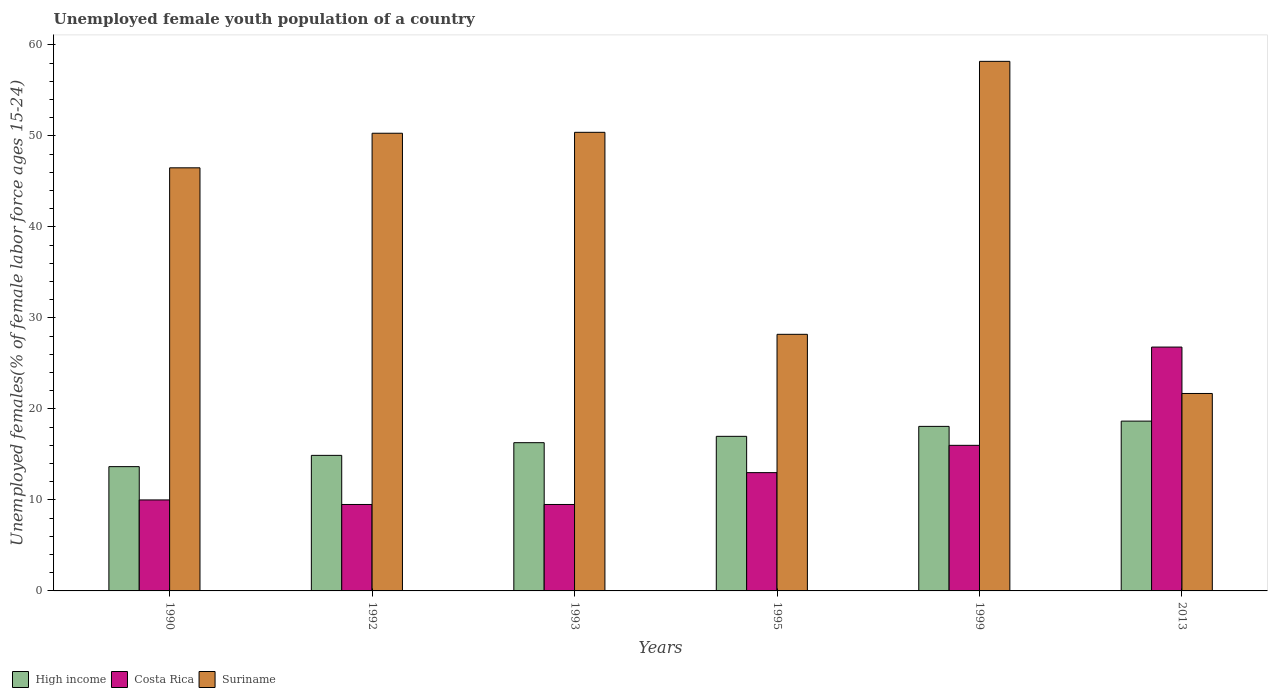What is the label of the 3rd group of bars from the left?
Your answer should be compact. 1993. What is the percentage of unemployed female youth population in Costa Rica in 1995?
Offer a very short reply. 13. Across all years, what is the maximum percentage of unemployed female youth population in Suriname?
Offer a very short reply. 58.2. Across all years, what is the minimum percentage of unemployed female youth population in Suriname?
Your response must be concise. 21.7. In which year was the percentage of unemployed female youth population in Costa Rica maximum?
Offer a terse response. 2013. In which year was the percentage of unemployed female youth population in High income minimum?
Make the answer very short. 1990. What is the total percentage of unemployed female youth population in High income in the graph?
Provide a succinct answer. 98.58. What is the difference between the percentage of unemployed female youth population in Costa Rica in 1990 and that in 2013?
Give a very brief answer. -16.8. What is the difference between the percentage of unemployed female youth population in High income in 1993 and the percentage of unemployed female youth population in Costa Rica in 1990?
Your answer should be compact. 6.29. What is the average percentage of unemployed female youth population in Costa Rica per year?
Keep it short and to the point. 14.13. In the year 1999, what is the difference between the percentage of unemployed female youth population in High income and percentage of unemployed female youth population in Costa Rica?
Give a very brief answer. 2.08. In how many years, is the percentage of unemployed female youth population in Suriname greater than 6 %?
Give a very brief answer. 6. Is the percentage of unemployed female youth population in Costa Rica in 1992 less than that in 1993?
Your response must be concise. No. Is the difference between the percentage of unemployed female youth population in High income in 1993 and 2013 greater than the difference between the percentage of unemployed female youth population in Costa Rica in 1993 and 2013?
Make the answer very short. Yes. What is the difference between the highest and the second highest percentage of unemployed female youth population in High income?
Ensure brevity in your answer.  0.58. What is the difference between the highest and the lowest percentage of unemployed female youth population in Suriname?
Provide a succinct answer. 36.5. What does the 1st bar from the right in 1999 represents?
Your response must be concise. Suriname. Is it the case that in every year, the sum of the percentage of unemployed female youth population in High income and percentage of unemployed female youth population in Suriname is greater than the percentage of unemployed female youth population in Costa Rica?
Offer a terse response. Yes. How many years are there in the graph?
Provide a succinct answer. 6. Does the graph contain any zero values?
Offer a very short reply. No. Does the graph contain grids?
Your answer should be compact. No. What is the title of the graph?
Ensure brevity in your answer.  Unemployed female youth population of a country. Does "Congo (Republic)" appear as one of the legend labels in the graph?
Provide a succinct answer. No. What is the label or title of the X-axis?
Provide a succinct answer. Years. What is the label or title of the Y-axis?
Your answer should be very brief. Unemployed females(% of female labor force ages 15-24). What is the Unemployed females(% of female labor force ages 15-24) of High income in 1990?
Make the answer very short. 13.66. What is the Unemployed females(% of female labor force ages 15-24) of Suriname in 1990?
Your answer should be compact. 46.5. What is the Unemployed females(% of female labor force ages 15-24) of High income in 1992?
Your answer should be compact. 14.9. What is the Unemployed females(% of female labor force ages 15-24) of Suriname in 1992?
Your answer should be very brief. 50.3. What is the Unemployed females(% of female labor force ages 15-24) in High income in 1993?
Provide a succinct answer. 16.29. What is the Unemployed females(% of female labor force ages 15-24) in Suriname in 1993?
Offer a terse response. 50.4. What is the Unemployed females(% of female labor force ages 15-24) in High income in 1995?
Your response must be concise. 16.99. What is the Unemployed females(% of female labor force ages 15-24) of Suriname in 1995?
Your answer should be very brief. 28.2. What is the Unemployed females(% of female labor force ages 15-24) of High income in 1999?
Provide a short and direct response. 18.08. What is the Unemployed females(% of female labor force ages 15-24) in Suriname in 1999?
Provide a short and direct response. 58.2. What is the Unemployed females(% of female labor force ages 15-24) in High income in 2013?
Provide a succinct answer. 18.66. What is the Unemployed females(% of female labor force ages 15-24) of Costa Rica in 2013?
Give a very brief answer. 26.8. What is the Unemployed females(% of female labor force ages 15-24) in Suriname in 2013?
Your response must be concise. 21.7. Across all years, what is the maximum Unemployed females(% of female labor force ages 15-24) in High income?
Give a very brief answer. 18.66. Across all years, what is the maximum Unemployed females(% of female labor force ages 15-24) in Costa Rica?
Ensure brevity in your answer.  26.8. Across all years, what is the maximum Unemployed females(% of female labor force ages 15-24) in Suriname?
Make the answer very short. 58.2. Across all years, what is the minimum Unemployed females(% of female labor force ages 15-24) of High income?
Your response must be concise. 13.66. Across all years, what is the minimum Unemployed females(% of female labor force ages 15-24) of Costa Rica?
Your answer should be very brief. 9.5. Across all years, what is the minimum Unemployed females(% of female labor force ages 15-24) in Suriname?
Keep it short and to the point. 21.7. What is the total Unemployed females(% of female labor force ages 15-24) in High income in the graph?
Make the answer very short. 98.58. What is the total Unemployed females(% of female labor force ages 15-24) of Costa Rica in the graph?
Make the answer very short. 84.8. What is the total Unemployed females(% of female labor force ages 15-24) of Suriname in the graph?
Keep it short and to the point. 255.3. What is the difference between the Unemployed females(% of female labor force ages 15-24) in High income in 1990 and that in 1992?
Provide a short and direct response. -1.24. What is the difference between the Unemployed females(% of female labor force ages 15-24) in High income in 1990 and that in 1993?
Provide a short and direct response. -2.63. What is the difference between the Unemployed females(% of female labor force ages 15-24) of High income in 1990 and that in 1995?
Provide a short and direct response. -3.33. What is the difference between the Unemployed females(% of female labor force ages 15-24) in Suriname in 1990 and that in 1995?
Make the answer very short. 18.3. What is the difference between the Unemployed females(% of female labor force ages 15-24) of High income in 1990 and that in 1999?
Make the answer very short. -4.42. What is the difference between the Unemployed females(% of female labor force ages 15-24) in High income in 1990 and that in 2013?
Provide a succinct answer. -5. What is the difference between the Unemployed females(% of female labor force ages 15-24) in Costa Rica in 1990 and that in 2013?
Ensure brevity in your answer.  -16.8. What is the difference between the Unemployed females(% of female labor force ages 15-24) in Suriname in 1990 and that in 2013?
Keep it short and to the point. 24.8. What is the difference between the Unemployed females(% of female labor force ages 15-24) of High income in 1992 and that in 1993?
Offer a very short reply. -1.4. What is the difference between the Unemployed females(% of female labor force ages 15-24) in Costa Rica in 1992 and that in 1993?
Your response must be concise. 0. What is the difference between the Unemployed females(% of female labor force ages 15-24) in Suriname in 1992 and that in 1993?
Provide a succinct answer. -0.1. What is the difference between the Unemployed females(% of female labor force ages 15-24) of High income in 1992 and that in 1995?
Your answer should be very brief. -2.09. What is the difference between the Unemployed females(% of female labor force ages 15-24) of Suriname in 1992 and that in 1995?
Keep it short and to the point. 22.1. What is the difference between the Unemployed females(% of female labor force ages 15-24) in High income in 1992 and that in 1999?
Make the answer very short. -3.19. What is the difference between the Unemployed females(% of female labor force ages 15-24) in Costa Rica in 1992 and that in 1999?
Offer a terse response. -6.5. What is the difference between the Unemployed females(% of female labor force ages 15-24) in High income in 1992 and that in 2013?
Offer a very short reply. -3.76. What is the difference between the Unemployed females(% of female labor force ages 15-24) in Costa Rica in 1992 and that in 2013?
Provide a short and direct response. -17.3. What is the difference between the Unemployed females(% of female labor force ages 15-24) in Suriname in 1992 and that in 2013?
Ensure brevity in your answer.  28.6. What is the difference between the Unemployed females(% of female labor force ages 15-24) in High income in 1993 and that in 1995?
Provide a short and direct response. -0.7. What is the difference between the Unemployed females(% of female labor force ages 15-24) of Suriname in 1993 and that in 1995?
Provide a succinct answer. 22.2. What is the difference between the Unemployed females(% of female labor force ages 15-24) of High income in 1993 and that in 1999?
Offer a very short reply. -1.79. What is the difference between the Unemployed females(% of female labor force ages 15-24) in Costa Rica in 1993 and that in 1999?
Keep it short and to the point. -6.5. What is the difference between the Unemployed females(% of female labor force ages 15-24) of Suriname in 1993 and that in 1999?
Make the answer very short. -7.8. What is the difference between the Unemployed females(% of female labor force ages 15-24) in High income in 1993 and that in 2013?
Provide a short and direct response. -2.37. What is the difference between the Unemployed females(% of female labor force ages 15-24) in Costa Rica in 1993 and that in 2013?
Your response must be concise. -17.3. What is the difference between the Unemployed females(% of female labor force ages 15-24) of Suriname in 1993 and that in 2013?
Offer a terse response. 28.7. What is the difference between the Unemployed females(% of female labor force ages 15-24) of High income in 1995 and that in 1999?
Make the answer very short. -1.09. What is the difference between the Unemployed females(% of female labor force ages 15-24) of High income in 1995 and that in 2013?
Your response must be concise. -1.67. What is the difference between the Unemployed females(% of female labor force ages 15-24) in Costa Rica in 1995 and that in 2013?
Your answer should be compact. -13.8. What is the difference between the Unemployed females(% of female labor force ages 15-24) of Suriname in 1995 and that in 2013?
Provide a short and direct response. 6.5. What is the difference between the Unemployed females(% of female labor force ages 15-24) of High income in 1999 and that in 2013?
Your answer should be compact. -0.58. What is the difference between the Unemployed females(% of female labor force ages 15-24) of Suriname in 1999 and that in 2013?
Offer a very short reply. 36.5. What is the difference between the Unemployed females(% of female labor force ages 15-24) in High income in 1990 and the Unemployed females(% of female labor force ages 15-24) in Costa Rica in 1992?
Offer a very short reply. 4.16. What is the difference between the Unemployed females(% of female labor force ages 15-24) of High income in 1990 and the Unemployed females(% of female labor force ages 15-24) of Suriname in 1992?
Ensure brevity in your answer.  -36.64. What is the difference between the Unemployed females(% of female labor force ages 15-24) of Costa Rica in 1990 and the Unemployed females(% of female labor force ages 15-24) of Suriname in 1992?
Provide a succinct answer. -40.3. What is the difference between the Unemployed females(% of female labor force ages 15-24) in High income in 1990 and the Unemployed females(% of female labor force ages 15-24) in Costa Rica in 1993?
Your answer should be very brief. 4.16. What is the difference between the Unemployed females(% of female labor force ages 15-24) of High income in 1990 and the Unemployed females(% of female labor force ages 15-24) of Suriname in 1993?
Your answer should be very brief. -36.74. What is the difference between the Unemployed females(% of female labor force ages 15-24) of Costa Rica in 1990 and the Unemployed females(% of female labor force ages 15-24) of Suriname in 1993?
Provide a short and direct response. -40.4. What is the difference between the Unemployed females(% of female labor force ages 15-24) of High income in 1990 and the Unemployed females(% of female labor force ages 15-24) of Costa Rica in 1995?
Offer a very short reply. 0.66. What is the difference between the Unemployed females(% of female labor force ages 15-24) in High income in 1990 and the Unemployed females(% of female labor force ages 15-24) in Suriname in 1995?
Offer a very short reply. -14.54. What is the difference between the Unemployed females(% of female labor force ages 15-24) of Costa Rica in 1990 and the Unemployed females(% of female labor force ages 15-24) of Suriname in 1995?
Offer a very short reply. -18.2. What is the difference between the Unemployed females(% of female labor force ages 15-24) in High income in 1990 and the Unemployed females(% of female labor force ages 15-24) in Costa Rica in 1999?
Keep it short and to the point. -2.34. What is the difference between the Unemployed females(% of female labor force ages 15-24) of High income in 1990 and the Unemployed females(% of female labor force ages 15-24) of Suriname in 1999?
Ensure brevity in your answer.  -44.54. What is the difference between the Unemployed females(% of female labor force ages 15-24) of Costa Rica in 1990 and the Unemployed females(% of female labor force ages 15-24) of Suriname in 1999?
Your answer should be compact. -48.2. What is the difference between the Unemployed females(% of female labor force ages 15-24) of High income in 1990 and the Unemployed females(% of female labor force ages 15-24) of Costa Rica in 2013?
Ensure brevity in your answer.  -13.14. What is the difference between the Unemployed females(% of female labor force ages 15-24) in High income in 1990 and the Unemployed females(% of female labor force ages 15-24) in Suriname in 2013?
Make the answer very short. -8.04. What is the difference between the Unemployed females(% of female labor force ages 15-24) of Costa Rica in 1990 and the Unemployed females(% of female labor force ages 15-24) of Suriname in 2013?
Provide a succinct answer. -11.7. What is the difference between the Unemployed females(% of female labor force ages 15-24) of High income in 1992 and the Unemployed females(% of female labor force ages 15-24) of Costa Rica in 1993?
Offer a terse response. 5.4. What is the difference between the Unemployed females(% of female labor force ages 15-24) in High income in 1992 and the Unemployed females(% of female labor force ages 15-24) in Suriname in 1993?
Your answer should be very brief. -35.5. What is the difference between the Unemployed females(% of female labor force ages 15-24) of Costa Rica in 1992 and the Unemployed females(% of female labor force ages 15-24) of Suriname in 1993?
Provide a succinct answer. -40.9. What is the difference between the Unemployed females(% of female labor force ages 15-24) of High income in 1992 and the Unemployed females(% of female labor force ages 15-24) of Costa Rica in 1995?
Make the answer very short. 1.9. What is the difference between the Unemployed females(% of female labor force ages 15-24) in High income in 1992 and the Unemployed females(% of female labor force ages 15-24) in Suriname in 1995?
Your answer should be compact. -13.3. What is the difference between the Unemployed females(% of female labor force ages 15-24) of Costa Rica in 1992 and the Unemployed females(% of female labor force ages 15-24) of Suriname in 1995?
Your answer should be very brief. -18.7. What is the difference between the Unemployed females(% of female labor force ages 15-24) in High income in 1992 and the Unemployed females(% of female labor force ages 15-24) in Costa Rica in 1999?
Keep it short and to the point. -1.1. What is the difference between the Unemployed females(% of female labor force ages 15-24) in High income in 1992 and the Unemployed females(% of female labor force ages 15-24) in Suriname in 1999?
Give a very brief answer. -43.3. What is the difference between the Unemployed females(% of female labor force ages 15-24) of Costa Rica in 1992 and the Unemployed females(% of female labor force ages 15-24) of Suriname in 1999?
Keep it short and to the point. -48.7. What is the difference between the Unemployed females(% of female labor force ages 15-24) in High income in 1992 and the Unemployed females(% of female labor force ages 15-24) in Costa Rica in 2013?
Your answer should be very brief. -11.9. What is the difference between the Unemployed females(% of female labor force ages 15-24) in High income in 1992 and the Unemployed females(% of female labor force ages 15-24) in Suriname in 2013?
Provide a succinct answer. -6.8. What is the difference between the Unemployed females(% of female labor force ages 15-24) of Costa Rica in 1992 and the Unemployed females(% of female labor force ages 15-24) of Suriname in 2013?
Give a very brief answer. -12.2. What is the difference between the Unemployed females(% of female labor force ages 15-24) in High income in 1993 and the Unemployed females(% of female labor force ages 15-24) in Costa Rica in 1995?
Ensure brevity in your answer.  3.29. What is the difference between the Unemployed females(% of female labor force ages 15-24) of High income in 1993 and the Unemployed females(% of female labor force ages 15-24) of Suriname in 1995?
Your answer should be very brief. -11.91. What is the difference between the Unemployed females(% of female labor force ages 15-24) of Costa Rica in 1993 and the Unemployed females(% of female labor force ages 15-24) of Suriname in 1995?
Make the answer very short. -18.7. What is the difference between the Unemployed females(% of female labor force ages 15-24) of High income in 1993 and the Unemployed females(% of female labor force ages 15-24) of Costa Rica in 1999?
Ensure brevity in your answer.  0.29. What is the difference between the Unemployed females(% of female labor force ages 15-24) in High income in 1993 and the Unemployed females(% of female labor force ages 15-24) in Suriname in 1999?
Your answer should be very brief. -41.91. What is the difference between the Unemployed females(% of female labor force ages 15-24) in Costa Rica in 1993 and the Unemployed females(% of female labor force ages 15-24) in Suriname in 1999?
Your answer should be compact. -48.7. What is the difference between the Unemployed females(% of female labor force ages 15-24) in High income in 1993 and the Unemployed females(% of female labor force ages 15-24) in Costa Rica in 2013?
Offer a terse response. -10.51. What is the difference between the Unemployed females(% of female labor force ages 15-24) in High income in 1993 and the Unemployed females(% of female labor force ages 15-24) in Suriname in 2013?
Give a very brief answer. -5.41. What is the difference between the Unemployed females(% of female labor force ages 15-24) of Costa Rica in 1993 and the Unemployed females(% of female labor force ages 15-24) of Suriname in 2013?
Make the answer very short. -12.2. What is the difference between the Unemployed females(% of female labor force ages 15-24) in High income in 1995 and the Unemployed females(% of female labor force ages 15-24) in Costa Rica in 1999?
Ensure brevity in your answer.  0.99. What is the difference between the Unemployed females(% of female labor force ages 15-24) of High income in 1995 and the Unemployed females(% of female labor force ages 15-24) of Suriname in 1999?
Provide a succinct answer. -41.21. What is the difference between the Unemployed females(% of female labor force ages 15-24) in Costa Rica in 1995 and the Unemployed females(% of female labor force ages 15-24) in Suriname in 1999?
Give a very brief answer. -45.2. What is the difference between the Unemployed females(% of female labor force ages 15-24) of High income in 1995 and the Unemployed females(% of female labor force ages 15-24) of Costa Rica in 2013?
Make the answer very short. -9.81. What is the difference between the Unemployed females(% of female labor force ages 15-24) in High income in 1995 and the Unemployed females(% of female labor force ages 15-24) in Suriname in 2013?
Provide a short and direct response. -4.71. What is the difference between the Unemployed females(% of female labor force ages 15-24) in High income in 1999 and the Unemployed females(% of female labor force ages 15-24) in Costa Rica in 2013?
Provide a short and direct response. -8.72. What is the difference between the Unemployed females(% of female labor force ages 15-24) in High income in 1999 and the Unemployed females(% of female labor force ages 15-24) in Suriname in 2013?
Make the answer very short. -3.62. What is the difference between the Unemployed females(% of female labor force ages 15-24) in Costa Rica in 1999 and the Unemployed females(% of female labor force ages 15-24) in Suriname in 2013?
Your answer should be compact. -5.7. What is the average Unemployed females(% of female labor force ages 15-24) in High income per year?
Make the answer very short. 16.43. What is the average Unemployed females(% of female labor force ages 15-24) of Costa Rica per year?
Offer a terse response. 14.13. What is the average Unemployed females(% of female labor force ages 15-24) in Suriname per year?
Keep it short and to the point. 42.55. In the year 1990, what is the difference between the Unemployed females(% of female labor force ages 15-24) of High income and Unemployed females(% of female labor force ages 15-24) of Costa Rica?
Your answer should be compact. 3.66. In the year 1990, what is the difference between the Unemployed females(% of female labor force ages 15-24) of High income and Unemployed females(% of female labor force ages 15-24) of Suriname?
Provide a succinct answer. -32.84. In the year 1990, what is the difference between the Unemployed females(% of female labor force ages 15-24) of Costa Rica and Unemployed females(% of female labor force ages 15-24) of Suriname?
Offer a very short reply. -36.5. In the year 1992, what is the difference between the Unemployed females(% of female labor force ages 15-24) in High income and Unemployed females(% of female labor force ages 15-24) in Costa Rica?
Ensure brevity in your answer.  5.4. In the year 1992, what is the difference between the Unemployed females(% of female labor force ages 15-24) in High income and Unemployed females(% of female labor force ages 15-24) in Suriname?
Ensure brevity in your answer.  -35.4. In the year 1992, what is the difference between the Unemployed females(% of female labor force ages 15-24) of Costa Rica and Unemployed females(% of female labor force ages 15-24) of Suriname?
Offer a terse response. -40.8. In the year 1993, what is the difference between the Unemployed females(% of female labor force ages 15-24) in High income and Unemployed females(% of female labor force ages 15-24) in Costa Rica?
Offer a terse response. 6.79. In the year 1993, what is the difference between the Unemployed females(% of female labor force ages 15-24) in High income and Unemployed females(% of female labor force ages 15-24) in Suriname?
Keep it short and to the point. -34.11. In the year 1993, what is the difference between the Unemployed females(% of female labor force ages 15-24) in Costa Rica and Unemployed females(% of female labor force ages 15-24) in Suriname?
Provide a short and direct response. -40.9. In the year 1995, what is the difference between the Unemployed females(% of female labor force ages 15-24) in High income and Unemployed females(% of female labor force ages 15-24) in Costa Rica?
Your response must be concise. 3.99. In the year 1995, what is the difference between the Unemployed females(% of female labor force ages 15-24) in High income and Unemployed females(% of female labor force ages 15-24) in Suriname?
Provide a short and direct response. -11.21. In the year 1995, what is the difference between the Unemployed females(% of female labor force ages 15-24) of Costa Rica and Unemployed females(% of female labor force ages 15-24) of Suriname?
Give a very brief answer. -15.2. In the year 1999, what is the difference between the Unemployed females(% of female labor force ages 15-24) in High income and Unemployed females(% of female labor force ages 15-24) in Costa Rica?
Offer a very short reply. 2.08. In the year 1999, what is the difference between the Unemployed females(% of female labor force ages 15-24) in High income and Unemployed females(% of female labor force ages 15-24) in Suriname?
Ensure brevity in your answer.  -40.12. In the year 1999, what is the difference between the Unemployed females(% of female labor force ages 15-24) of Costa Rica and Unemployed females(% of female labor force ages 15-24) of Suriname?
Your response must be concise. -42.2. In the year 2013, what is the difference between the Unemployed females(% of female labor force ages 15-24) of High income and Unemployed females(% of female labor force ages 15-24) of Costa Rica?
Ensure brevity in your answer.  -8.14. In the year 2013, what is the difference between the Unemployed females(% of female labor force ages 15-24) in High income and Unemployed females(% of female labor force ages 15-24) in Suriname?
Provide a succinct answer. -3.04. In the year 2013, what is the difference between the Unemployed females(% of female labor force ages 15-24) in Costa Rica and Unemployed females(% of female labor force ages 15-24) in Suriname?
Your answer should be compact. 5.1. What is the ratio of the Unemployed females(% of female labor force ages 15-24) in High income in 1990 to that in 1992?
Provide a short and direct response. 0.92. What is the ratio of the Unemployed females(% of female labor force ages 15-24) of Costa Rica in 1990 to that in 1992?
Provide a succinct answer. 1.05. What is the ratio of the Unemployed females(% of female labor force ages 15-24) of Suriname in 1990 to that in 1992?
Offer a very short reply. 0.92. What is the ratio of the Unemployed females(% of female labor force ages 15-24) in High income in 1990 to that in 1993?
Offer a very short reply. 0.84. What is the ratio of the Unemployed females(% of female labor force ages 15-24) of Costa Rica in 1990 to that in 1993?
Provide a short and direct response. 1.05. What is the ratio of the Unemployed females(% of female labor force ages 15-24) in Suriname in 1990 to that in 1993?
Offer a very short reply. 0.92. What is the ratio of the Unemployed females(% of female labor force ages 15-24) of High income in 1990 to that in 1995?
Make the answer very short. 0.8. What is the ratio of the Unemployed females(% of female labor force ages 15-24) of Costa Rica in 1990 to that in 1995?
Keep it short and to the point. 0.77. What is the ratio of the Unemployed females(% of female labor force ages 15-24) in Suriname in 1990 to that in 1995?
Offer a terse response. 1.65. What is the ratio of the Unemployed females(% of female labor force ages 15-24) of High income in 1990 to that in 1999?
Your answer should be compact. 0.76. What is the ratio of the Unemployed females(% of female labor force ages 15-24) of Suriname in 1990 to that in 1999?
Your answer should be compact. 0.8. What is the ratio of the Unemployed females(% of female labor force ages 15-24) in High income in 1990 to that in 2013?
Make the answer very short. 0.73. What is the ratio of the Unemployed females(% of female labor force ages 15-24) of Costa Rica in 1990 to that in 2013?
Make the answer very short. 0.37. What is the ratio of the Unemployed females(% of female labor force ages 15-24) of Suriname in 1990 to that in 2013?
Your response must be concise. 2.14. What is the ratio of the Unemployed females(% of female labor force ages 15-24) in High income in 1992 to that in 1993?
Your response must be concise. 0.91. What is the ratio of the Unemployed females(% of female labor force ages 15-24) in High income in 1992 to that in 1995?
Ensure brevity in your answer.  0.88. What is the ratio of the Unemployed females(% of female labor force ages 15-24) in Costa Rica in 1992 to that in 1995?
Offer a terse response. 0.73. What is the ratio of the Unemployed females(% of female labor force ages 15-24) of Suriname in 1992 to that in 1995?
Your response must be concise. 1.78. What is the ratio of the Unemployed females(% of female labor force ages 15-24) of High income in 1992 to that in 1999?
Offer a terse response. 0.82. What is the ratio of the Unemployed females(% of female labor force ages 15-24) of Costa Rica in 1992 to that in 1999?
Give a very brief answer. 0.59. What is the ratio of the Unemployed females(% of female labor force ages 15-24) of Suriname in 1992 to that in 1999?
Provide a short and direct response. 0.86. What is the ratio of the Unemployed females(% of female labor force ages 15-24) in High income in 1992 to that in 2013?
Offer a very short reply. 0.8. What is the ratio of the Unemployed females(% of female labor force ages 15-24) of Costa Rica in 1992 to that in 2013?
Make the answer very short. 0.35. What is the ratio of the Unemployed females(% of female labor force ages 15-24) of Suriname in 1992 to that in 2013?
Offer a very short reply. 2.32. What is the ratio of the Unemployed females(% of female labor force ages 15-24) in Costa Rica in 1993 to that in 1995?
Your response must be concise. 0.73. What is the ratio of the Unemployed females(% of female labor force ages 15-24) in Suriname in 1993 to that in 1995?
Your answer should be very brief. 1.79. What is the ratio of the Unemployed females(% of female labor force ages 15-24) in High income in 1993 to that in 1999?
Offer a very short reply. 0.9. What is the ratio of the Unemployed females(% of female labor force ages 15-24) of Costa Rica in 1993 to that in 1999?
Make the answer very short. 0.59. What is the ratio of the Unemployed females(% of female labor force ages 15-24) in Suriname in 1993 to that in 1999?
Offer a terse response. 0.87. What is the ratio of the Unemployed females(% of female labor force ages 15-24) of High income in 1993 to that in 2013?
Ensure brevity in your answer.  0.87. What is the ratio of the Unemployed females(% of female labor force ages 15-24) of Costa Rica in 1993 to that in 2013?
Your answer should be compact. 0.35. What is the ratio of the Unemployed females(% of female labor force ages 15-24) of Suriname in 1993 to that in 2013?
Your answer should be compact. 2.32. What is the ratio of the Unemployed females(% of female labor force ages 15-24) in High income in 1995 to that in 1999?
Keep it short and to the point. 0.94. What is the ratio of the Unemployed females(% of female labor force ages 15-24) in Costa Rica in 1995 to that in 1999?
Provide a short and direct response. 0.81. What is the ratio of the Unemployed females(% of female labor force ages 15-24) of Suriname in 1995 to that in 1999?
Give a very brief answer. 0.48. What is the ratio of the Unemployed females(% of female labor force ages 15-24) in High income in 1995 to that in 2013?
Provide a succinct answer. 0.91. What is the ratio of the Unemployed females(% of female labor force ages 15-24) of Costa Rica in 1995 to that in 2013?
Offer a terse response. 0.49. What is the ratio of the Unemployed females(% of female labor force ages 15-24) in Suriname in 1995 to that in 2013?
Ensure brevity in your answer.  1.3. What is the ratio of the Unemployed females(% of female labor force ages 15-24) of Costa Rica in 1999 to that in 2013?
Ensure brevity in your answer.  0.6. What is the ratio of the Unemployed females(% of female labor force ages 15-24) in Suriname in 1999 to that in 2013?
Provide a short and direct response. 2.68. What is the difference between the highest and the second highest Unemployed females(% of female labor force ages 15-24) of High income?
Give a very brief answer. 0.58. What is the difference between the highest and the second highest Unemployed females(% of female labor force ages 15-24) of Suriname?
Provide a short and direct response. 7.8. What is the difference between the highest and the lowest Unemployed females(% of female labor force ages 15-24) in High income?
Provide a succinct answer. 5. What is the difference between the highest and the lowest Unemployed females(% of female labor force ages 15-24) in Suriname?
Keep it short and to the point. 36.5. 